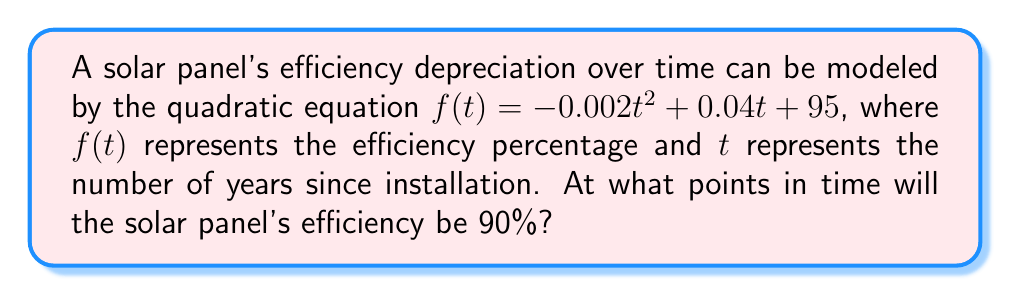Can you solve this math problem? To find the points in time when the solar panel's efficiency will be 90%, we need to solve the equation:

$f(t) = 90$

Substituting the given function:

$-0.002t^2 + 0.04t + 95 = 90$

Rearranging the equation to standard form:

$-0.002t^2 + 0.04t + 5 = 0$

Multiply all terms by -500 to simplify coefficients:

$t^2 - 20t - 2500 = 0$

This is now in the standard form of a quadratic equation: $at^2 + bt + c = 0$, where $a=1$, $b=-20$, and $c=-2500$.

We can solve this using the quadratic formula: $t = \frac{-b \pm \sqrt{b^2 - 4ac}}{2a}$

Substituting the values:

$t = \frac{20 \pm \sqrt{(-20)^2 - 4(1)(-2500)}}{2(1)}$

$t = \frac{20 \pm \sqrt{400 + 10000}}{2}$

$t = \frac{20 \pm \sqrt{10400}}{2}$

$t = \frac{20 \pm 102}{2}$

This gives us two solutions:

$t_1 = \frac{20 + 102}{2} = 61$ years

$t_2 = \frac{20 - 102}{2} = -41$ years

Since time cannot be negative in this context, we discard the negative solution.
Answer: 61 years 